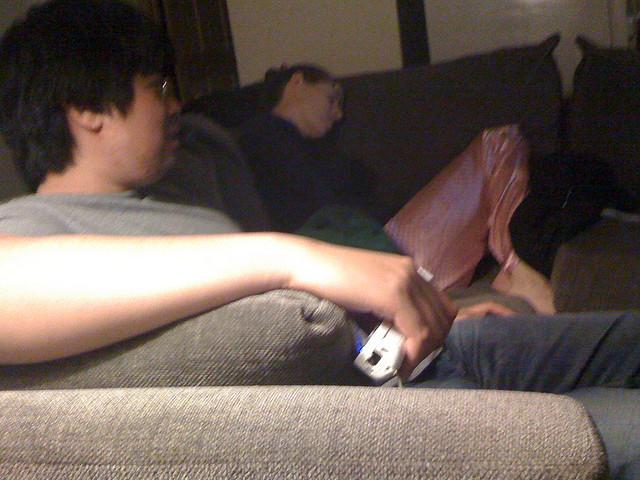What are the people sitting on?
Give a very brief answer. Couch. What color is the couch?
Answer briefly. Gray. What color are the girl's pants?
Quick response, please. Pink. 